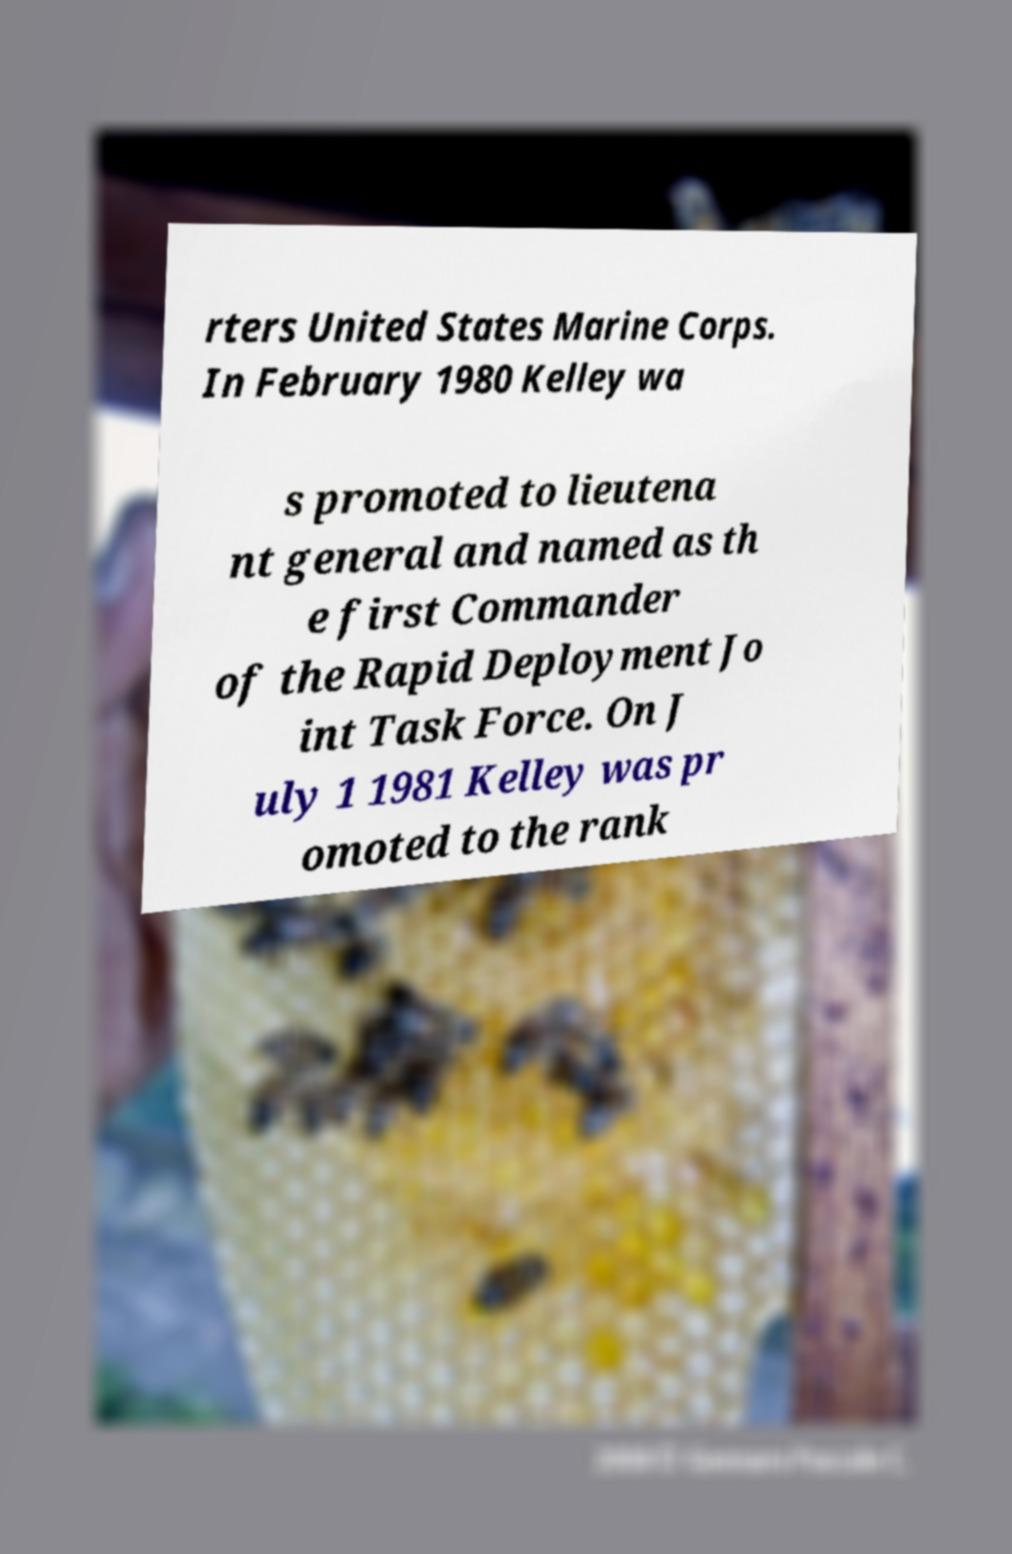What messages or text are displayed in this image? I need them in a readable, typed format. rters United States Marine Corps. In February 1980 Kelley wa s promoted to lieutena nt general and named as th e first Commander of the Rapid Deployment Jo int Task Force. On J uly 1 1981 Kelley was pr omoted to the rank 